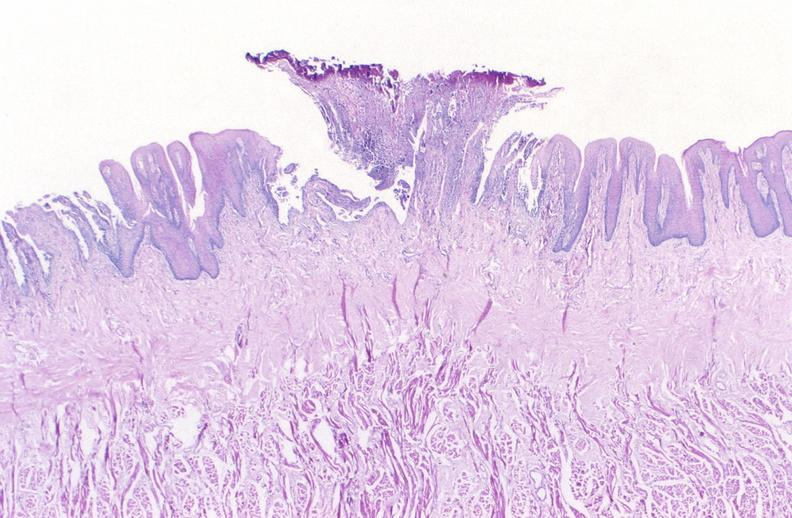what does this image show?
Answer the question using a single word or phrase. Tongue 